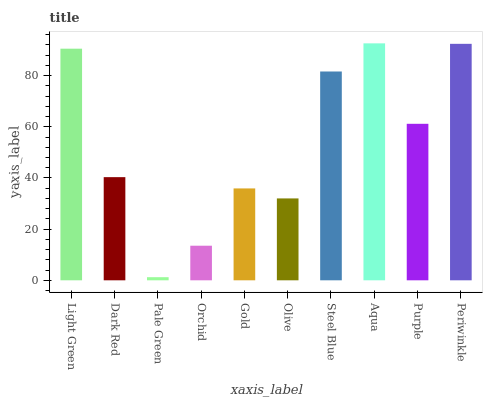Is Dark Red the minimum?
Answer yes or no. No. Is Dark Red the maximum?
Answer yes or no. No. Is Light Green greater than Dark Red?
Answer yes or no. Yes. Is Dark Red less than Light Green?
Answer yes or no. Yes. Is Dark Red greater than Light Green?
Answer yes or no. No. Is Light Green less than Dark Red?
Answer yes or no. No. Is Purple the high median?
Answer yes or no. Yes. Is Dark Red the low median?
Answer yes or no. Yes. Is Aqua the high median?
Answer yes or no. No. Is Purple the low median?
Answer yes or no. No. 